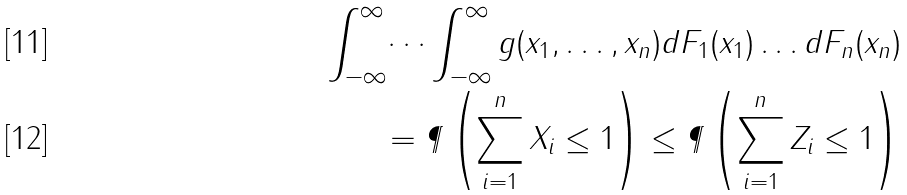<formula> <loc_0><loc_0><loc_500><loc_500>\int _ { - \infty } ^ { \infty } \dots \int _ { - \infty } ^ { \infty } g ( x _ { 1 } , \dots , x _ { n } ) d F _ { 1 } ( x _ { 1 } ) \dots d F _ { n } ( x _ { n } ) \\ = \P \left ( \sum _ { i = 1 } ^ { n } X _ { i } \leq 1 \right ) \leq \P \left ( \sum _ { i = 1 } ^ { n } Z _ { i } \leq 1 \right )</formula> 